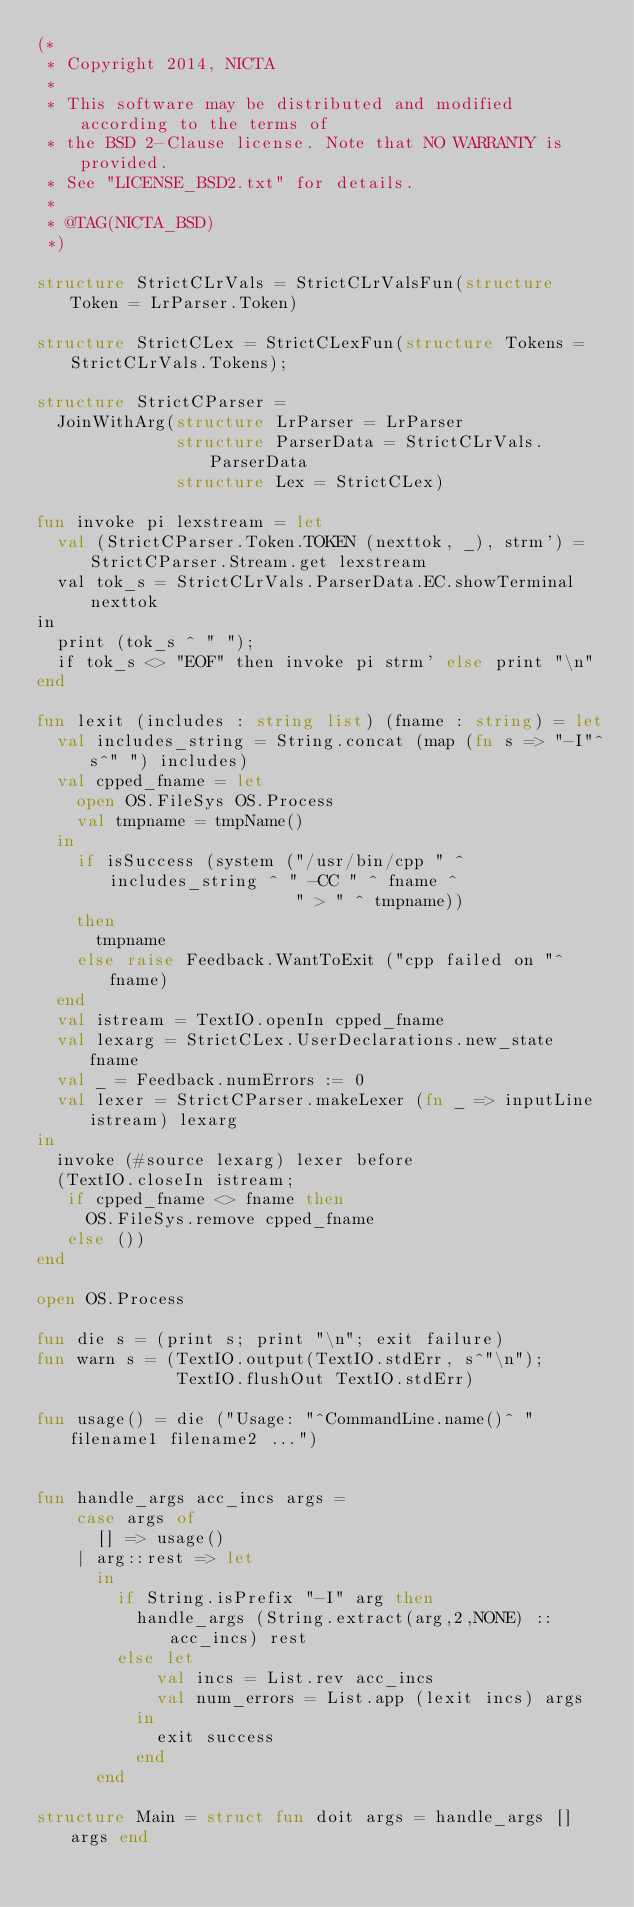Convert code to text. <code><loc_0><loc_0><loc_500><loc_500><_SML_>(*
 * Copyright 2014, NICTA
 *
 * This software may be distributed and modified according to the terms of
 * the BSD 2-Clause license. Note that NO WARRANTY is provided.
 * See "LICENSE_BSD2.txt" for details.
 *
 * @TAG(NICTA_BSD)
 *)

structure StrictCLrVals = StrictCLrValsFun(structure Token = LrParser.Token)

structure StrictCLex = StrictCLexFun(structure Tokens = StrictCLrVals.Tokens);

structure StrictCParser =
  JoinWithArg(structure LrParser = LrParser
              structure ParserData = StrictCLrVals.ParserData
              structure Lex = StrictCLex)

fun invoke pi lexstream = let
  val (StrictCParser.Token.TOKEN (nexttok, _), strm') = StrictCParser.Stream.get lexstream
  val tok_s = StrictCLrVals.ParserData.EC.showTerminal nexttok
in
  print (tok_s ^ " ");
  if tok_s <> "EOF" then invoke pi strm' else print "\n"
end

fun lexit (includes : string list) (fname : string) = let
  val includes_string = String.concat (map (fn s => "-I"^s^" ") includes)
  val cpped_fname = let
    open OS.FileSys OS.Process
    val tmpname = tmpName()
  in
    if isSuccess (system ("/usr/bin/cpp " ^ includes_string ^ " -CC " ^ fname ^
                          " > " ^ tmpname))
    then
      tmpname
    else raise Feedback.WantToExit ("cpp failed on "^fname)
  end
  val istream = TextIO.openIn cpped_fname
  val lexarg = StrictCLex.UserDeclarations.new_state fname
  val _ = Feedback.numErrors := 0
  val lexer = StrictCParser.makeLexer (fn _ => inputLine istream) lexarg
in
  invoke (#source lexarg) lexer before
  (TextIO.closeIn istream;
   if cpped_fname <> fname then
     OS.FileSys.remove cpped_fname
   else ())
end

open OS.Process

fun die s = (print s; print "\n"; exit failure)
fun warn s = (TextIO.output(TextIO.stdErr, s^"\n");
              TextIO.flushOut TextIO.stdErr)

fun usage() = die ("Usage: "^CommandLine.name()^ " filename1 filename2 ...")


fun handle_args acc_incs args =
    case args of
      [] => usage()
    | arg::rest => let
      in
        if String.isPrefix "-I" arg then
          handle_args (String.extract(arg,2,NONE) :: acc_incs) rest
        else let
            val incs = List.rev acc_incs
            val num_errors = List.app (lexit incs) args
          in
            exit success
          end
      end

structure Main = struct fun doit args = handle_args [] args end
</code> 